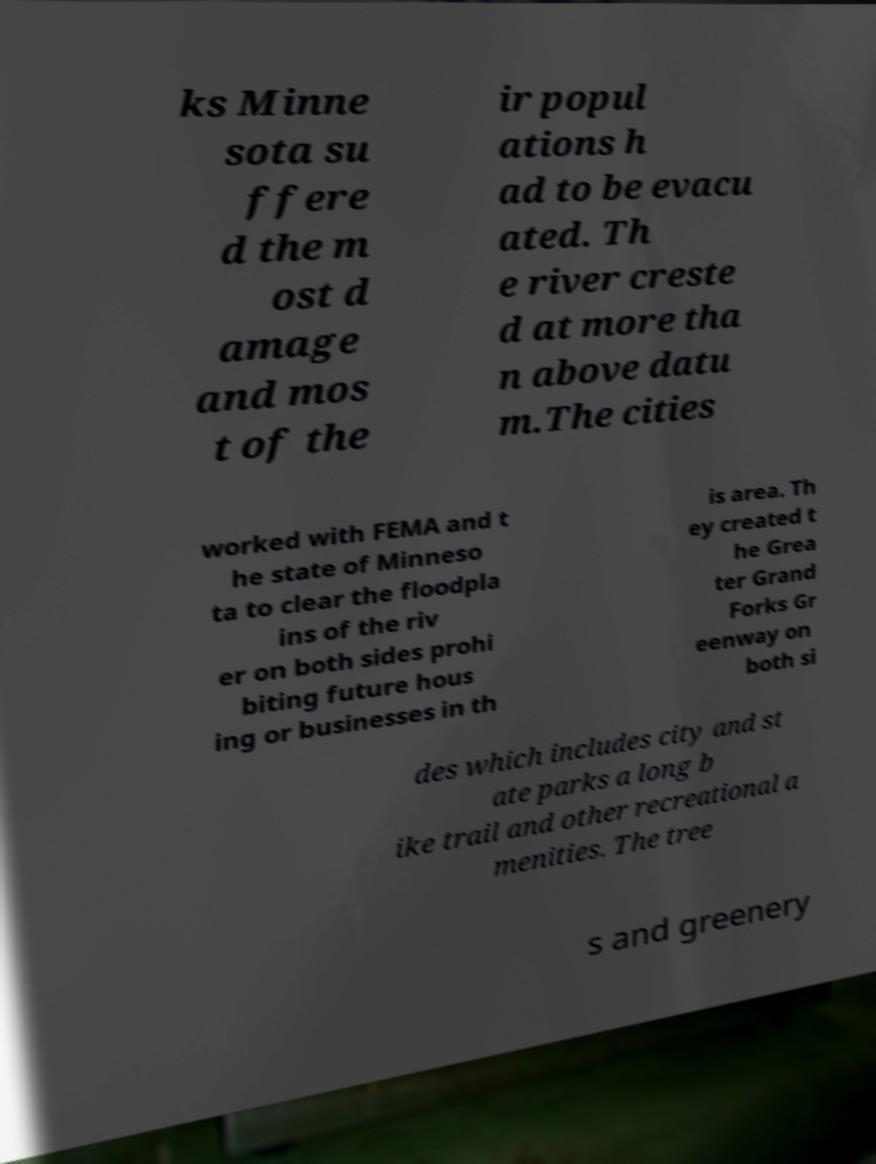I need the written content from this picture converted into text. Can you do that? ks Minne sota su ffere d the m ost d amage and mos t of the ir popul ations h ad to be evacu ated. Th e river creste d at more tha n above datu m.The cities worked with FEMA and t he state of Minneso ta to clear the floodpla ins of the riv er on both sides prohi biting future hous ing or businesses in th is area. Th ey created t he Grea ter Grand Forks Gr eenway on both si des which includes city and st ate parks a long b ike trail and other recreational a menities. The tree s and greenery 